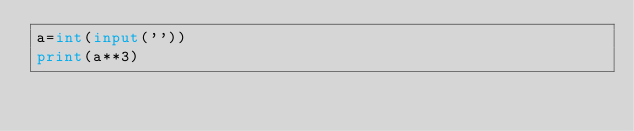<code> <loc_0><loc_0><loc_500><loc_500><_Python_>a=int(input(''))
print(a**3)
</code> 